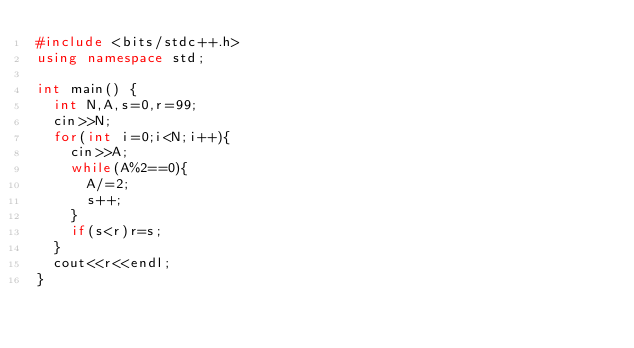Convert code to text. <code><loc_0><loc_0><loc_500><loc_500><_C++_>#include <bits/stdc++.h>
using namespace std;

int main() {
  int N,A,s=0,r=99;
  cin>>N;
  for(int i=0;i<N;i++){
    cin>>A;
    while(A%2==0){
      A/=2;
      s++;
    }
    if(s<r)r=s;
  }
  cout<<r<<endl;
}</code> 